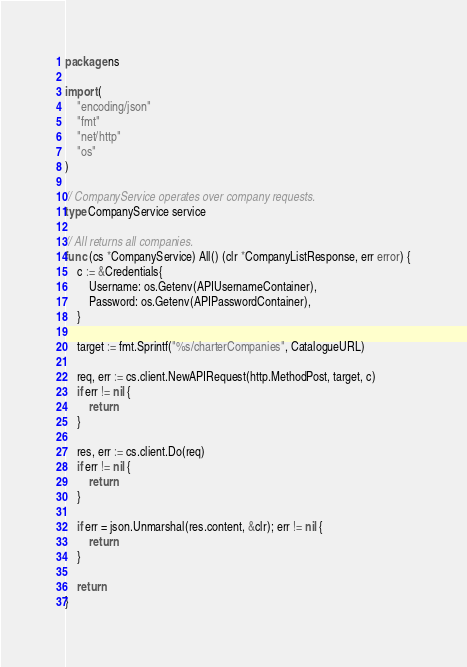<code> <loc_0><loc_0><loc_500><loc_500><_Go_>package ns

import (
	"encoding/json"
	"fmt"
	"net/http"
	"os"
)

// CompanyService operates over company requests.
type CompanyService service

// All returns all companies.
func (cs *CompanyService) All() (clr *CompanyListResponse, err error) {
	c := &Credentials{
		Username: os.Getenv(APIUsernameContainer),
		Password: os.Getenv(APIPasswordContainer),
	}

	target := fmt.Sprintf("%s/charterCompanies", CatalogueURL)

	req, err := cs.client.NewAPIRequest(http.MethodPost, target, c)
	if err != nil {
		return
	}

	res, err := cs.client.Do(req)
	if err != nil {
		return
	}

	if err = json.Unmarshal(res.content, &clr); err != nil {
		return
	}

	return
}
</code> 